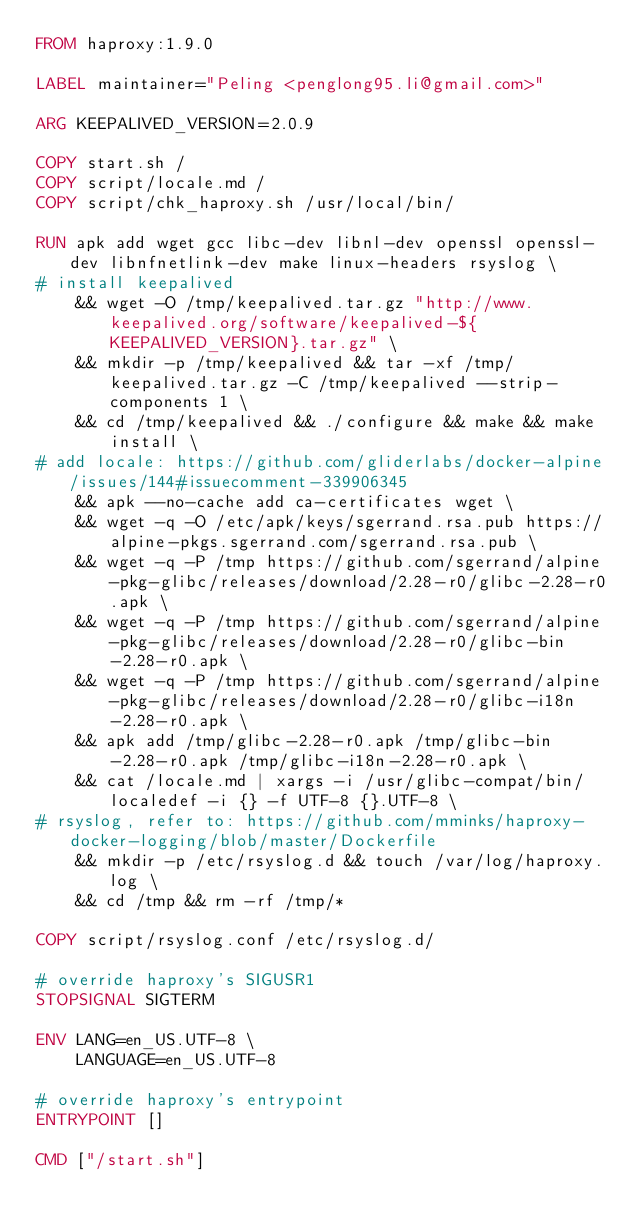<code> <loc_0><loc_0><loc_500><loc_500><_Dockerfile_>FROM haproxy:1.9.0

LABEL maintainer="Peling <penglong95.li@gmail.com>"

ARG KEEPALIVED_VERSION=2.0.9

COPY start.sh /
COPY script/locale.md /
COPY script/chk_haproxy.sh /usr/local/bin/ 

RUN apk add wget gcc libc-dev libnl-dev openssl openssl-dev libnfnetlink-dev make linux-headers rsyslog \
# install keepalived
    && wget -O /tmp/keepalived.tar.gz "http://www.keepalived.org/software/keepalived-${KEEPALIVED_VERSION}.tar.gz" \
    && mkdir -p /tmp/keepalived && tar -xf /tmp/keepalived.tar.gz -C /tmp/keepalived --strip-components 1 \
    && cd /tmp/keepalived && ./configure && make && make install \
# add locale: https://github.com/gliderlabs/docker-alpine/issues/144#issuecomment-339906345
    && apk --no-cache add ca-certificates wget \
    && wget -q -O /etc/apk/keys/sgerrand.rsa.pub https://alpine-pkgs.sgerrand.com/sgerrand.rsa.pub \
    && wget -q -P /tmp https://github.com/sgerrand/alpine-pkg-glibc/releases/download/2.28-r0/glibc-2.28-r0.apk \
    && wget -q -P /tmp https://github.com/sgerrand/alpine-pkg-glibc/releases/download/2.28-r0/glibc-bin-2.28-r0.apk \
    && wget -q -P /tmp https://github.com/sgerrand/alpine-pkg-glibc/releases/download/2.28-r0/glibc-i18n-2.28-r0.apk \
    && apk add /tmp/glibc-2.28-r0.apk /tmp/glibc-bin-2.28-r0.apk /tmp/glibc-i18n-2.28-r0.apk \
    && cat /locale.md | xargs -i /usr/glibc-compat/bin/localedef -i {} -f UTF-8 {}.UTF-8 \
# rsyslog, refer to: https://github.com/mminks/haproxy-docker-logging/blob/master/Dockerfile
    && mkdir -p /etc/rsyslog.d && touch /var/log/haproxy.log \
    && cd /tmp && rm -rf /tmp/*

COPY script/rsyslog.conf /etc/rsyslog.d/

# override haproxy's SIGUSR1 
STOPSIGNAL SIGTERM 

ENV LANG=en_US.UTF-8 \
    LANGUAGE=en_US.UTF-8

# override haproxy's entrypoint
ENTRYPOINT []

CMD ["/start.sh"]
</code> 